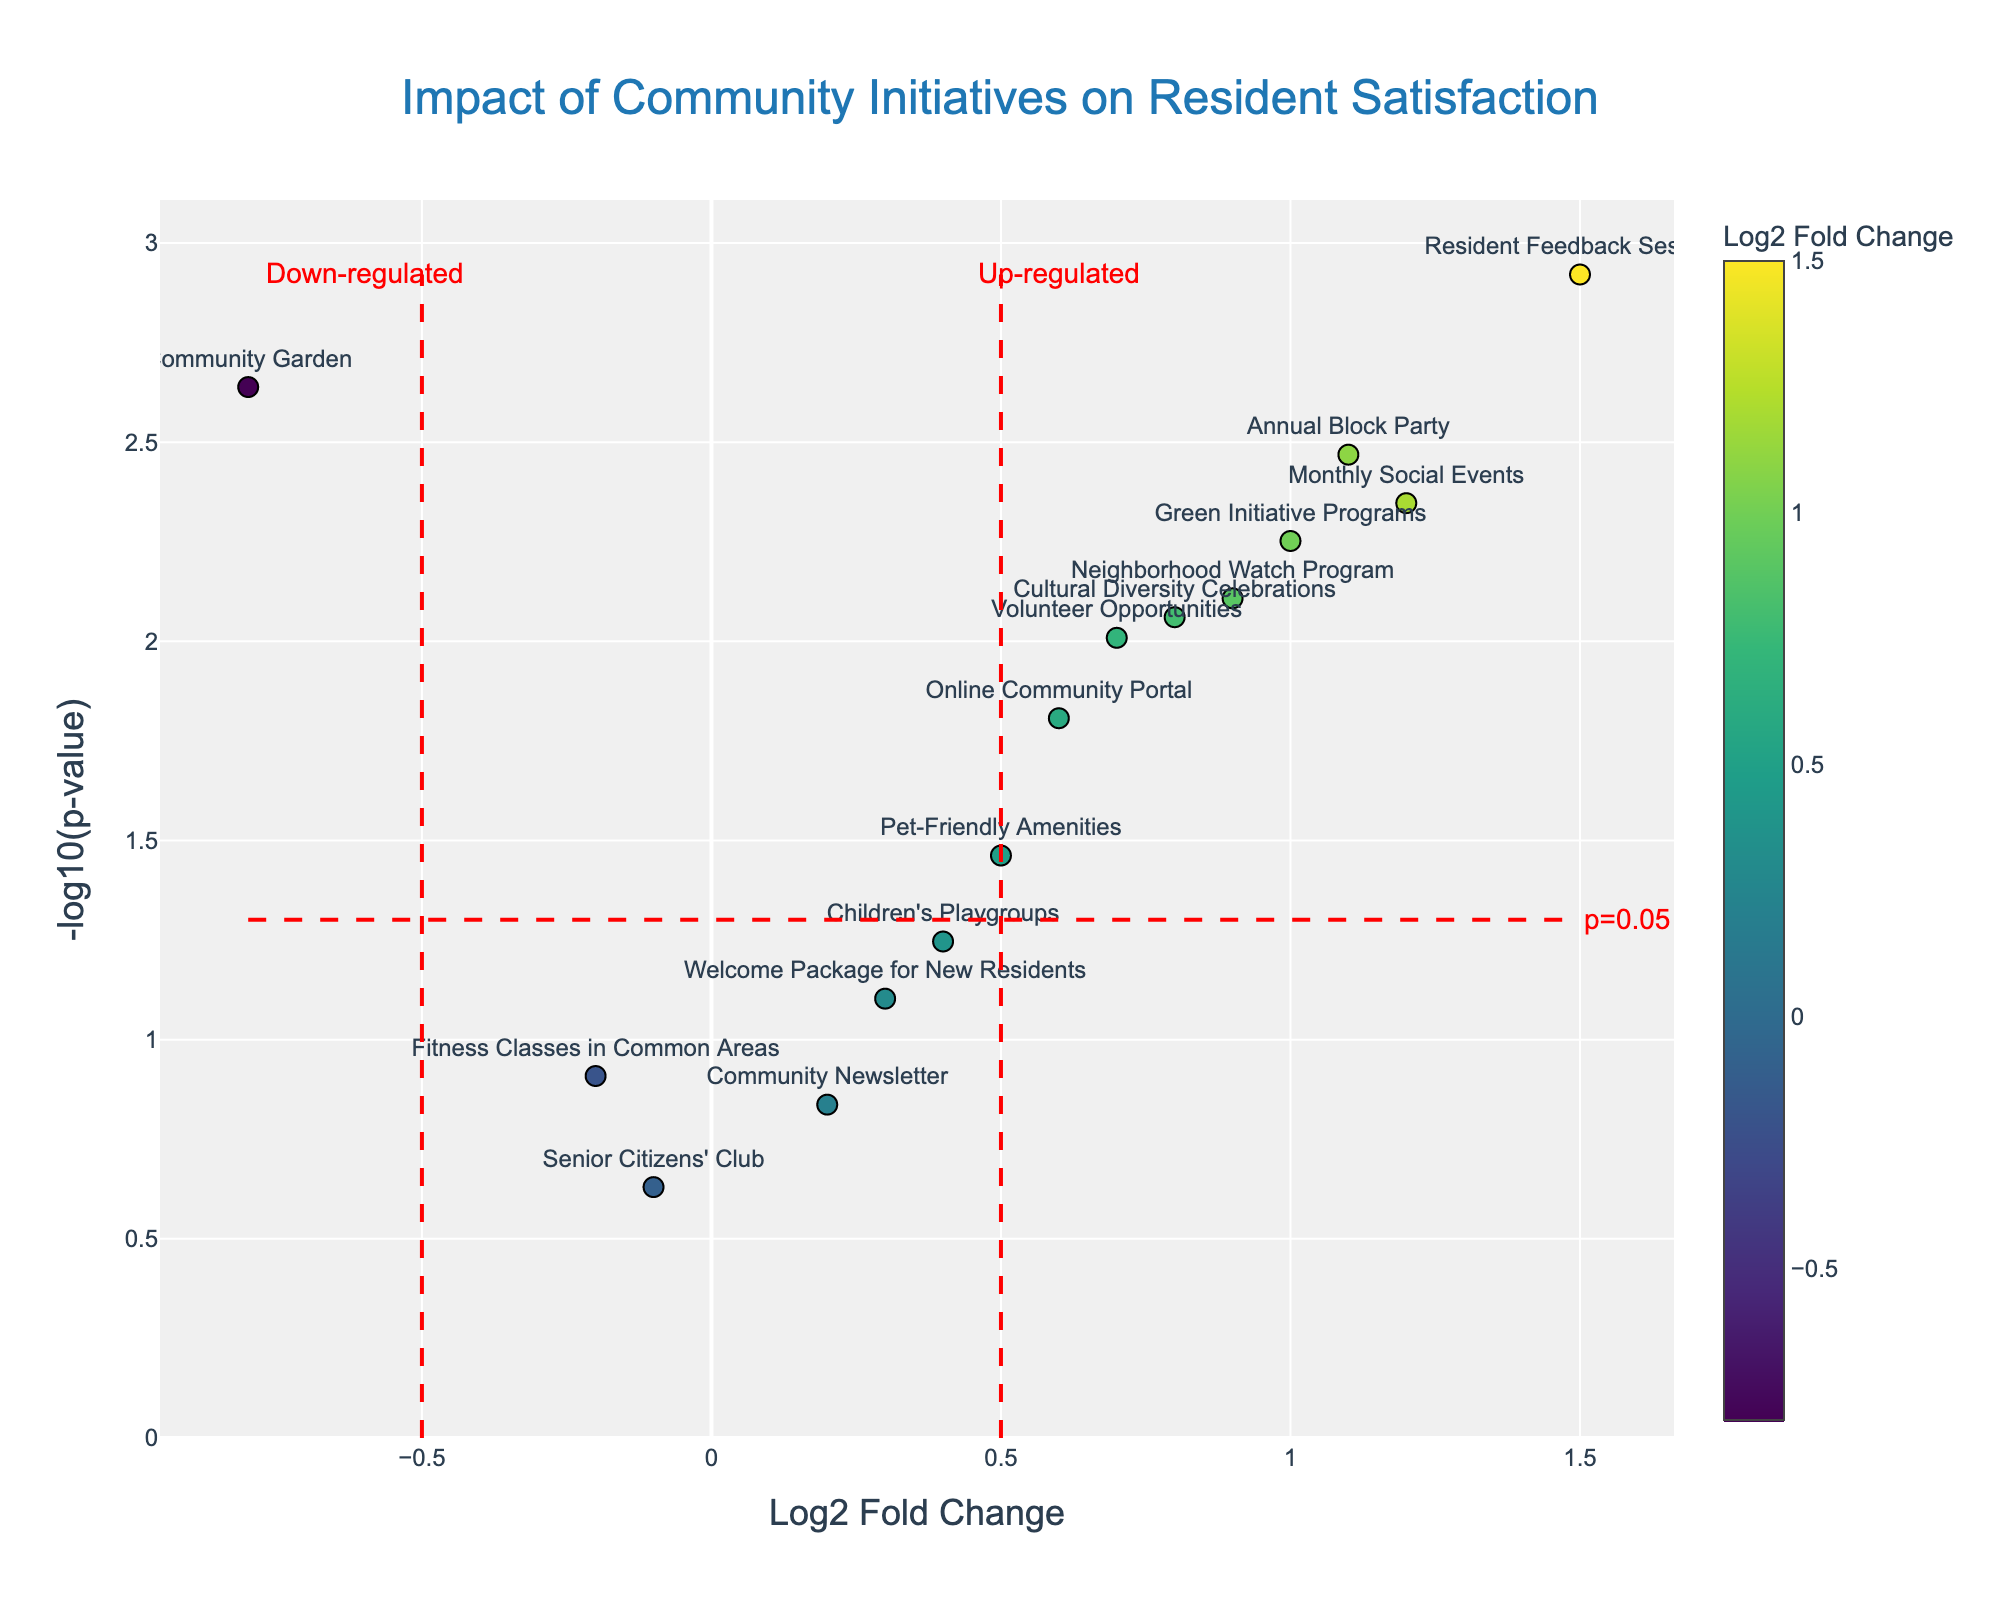Which initiative shows the highest fold change? The initiative with the highest fold change is determined by the value farthest to the right on the x-axis. The figure shows that "Resident Feedback Sessions" has the highest fold change with a Log2 Fold Change of 1.5.
Answer: Resident Feedback Sessions Which initiative has the most significant p-value? The most significant p-value is the lowest p-value. It is represented by the highest point on the y-axis. The figure indicates that "Resident Feedback Sessions" is the highest point with a -log10(p-value) value corresponding to a p-value of 0.0012.
Answer: Resident Feedback Sessions How many initiatives are considered up-regulated (positive log2 fold change) and are significant (p-value < 0.05)? Up-regulated initiatives are those with a positive Log2 Fold Change (to the right of the x=0 line), and significant ones have p-values less than 0.05 (above the horizontal red dashed line at -log10(0.05)). The significant up-regulated initiatives are: Monthly Social Events, Resident Feedback Sessions, Neighborhood Watch Program, Annual Block Party, Green Initiative Programs, and Cultural Diversity Celebrations; totaling 6.
Answer: 6 What initiative is down-regulated and significant? Down-regulated initiatives have a negative Log2 Fold Change (to the left of the x=0 line), and significant are above the horizontal red line at -log10(0.05). The only down-regulated significant initiative is "Community Garden."
Answer: Community Garden Which initiative is closest to the least significant p-value threshold (p=0.05) but not considered significant? Initiatives close to the significance threshold have values near the horizontal red dashed line at -log10(0.05) but below it. "Children's Playgroups" is just under the significance line with a p-value of 0.0567.
Answer: Children's Playgroups Which initiatives are neither significantly up-regulated nor significantly down-regulated? Initiatives that are neither significantly up-regulated nor down-regulated are the ones not beyond the red lines delimiting up-regulation and down-regulation, and not above the significance line at -log10(0.05). The initiatives in this region include Fitness Classes in Common Areas, Senior Citizens' Club, Welcome Package for New Residents, and Community Newsletter.
Answer: Fitness Classes in Common Areas, Senior Citizens' Club, Welcome Package for New Residents, Community Newsletter 